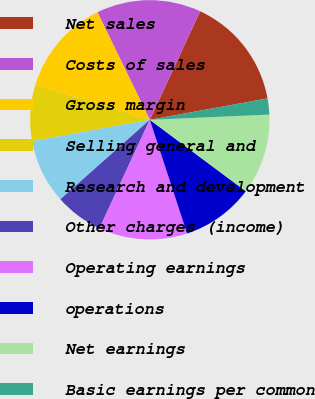Convert chart. <chart><loc_0><loc_0><loc_500><loc_500><pie_chart><fcel>Net sales<fcel>Costs of sales<fcel>Gross margin<fcel>Selling general and<fcel>Research and development<fcel>Other charges (income)<fcel>Operating earnings<fcel>operations<fcel>Net earnings<fcel>Basic earnings per common<nl><fcel>15.22%<fcel>14.13%<fcel>13.04%<fcel>7.61%<fcel>8.7%<fcel>6.52%<fcel>11.96%<fcel>9.78%<fcel>10.87%<fcel>2.17%<nl></chart> 